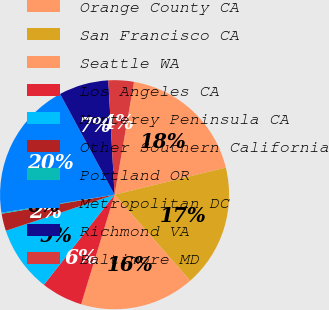<chart> <loc_0><loc_0><loc_500><loc_500><pie_chart><fcel>Orange County CA<fcel>San Francisco CA<fcel>Seattle WA<fcel>Los Angeles CA<fcel>Monterey Peninsula CA<fcel>Other Southern California<fcel>Portland OR<fcel>Metropolitan DC<fcel>Richmond VA<fcel>Baltimore MD<nl><fcel>18.48%<fcel>17.33%<fcel>16.19%<fcel>5.88%<fcel>9.31%<fcel>2.44%<fcel>0.15%<fcel>19.62%<fcel>7.02%<fcel>3.58%<nl></chart> 